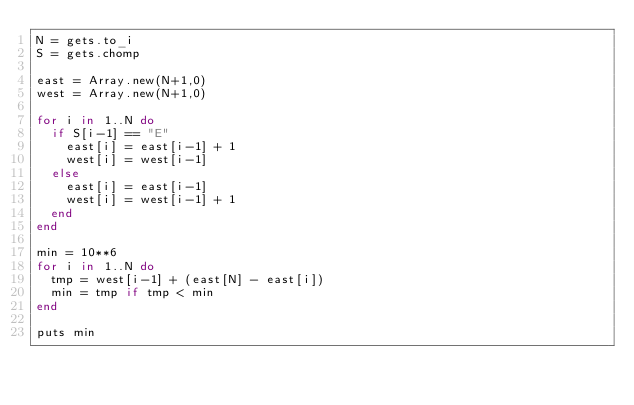Convert code to text. <code><loc_0><loc_0><loc_500><loc_500><_Ruby_>N = gets.to_i
S = gets.chomp

east = Array.new(N+1,0)
west = Array.new(N+1,0)

for i in 1..N do
  if S[i-1] == "E"
    east[i] = east[i-1] + 1
    west[i] = west[i-1]
  else
    east[i] = east[i-1]
    west[i] = west[i-1] + 1
  end
end

min = 10**6
for i in 1..N do
  tmp = west[i-1] + (east[N] - east[i])
  min = tmp if tmp < min
end

puts min
</code> 